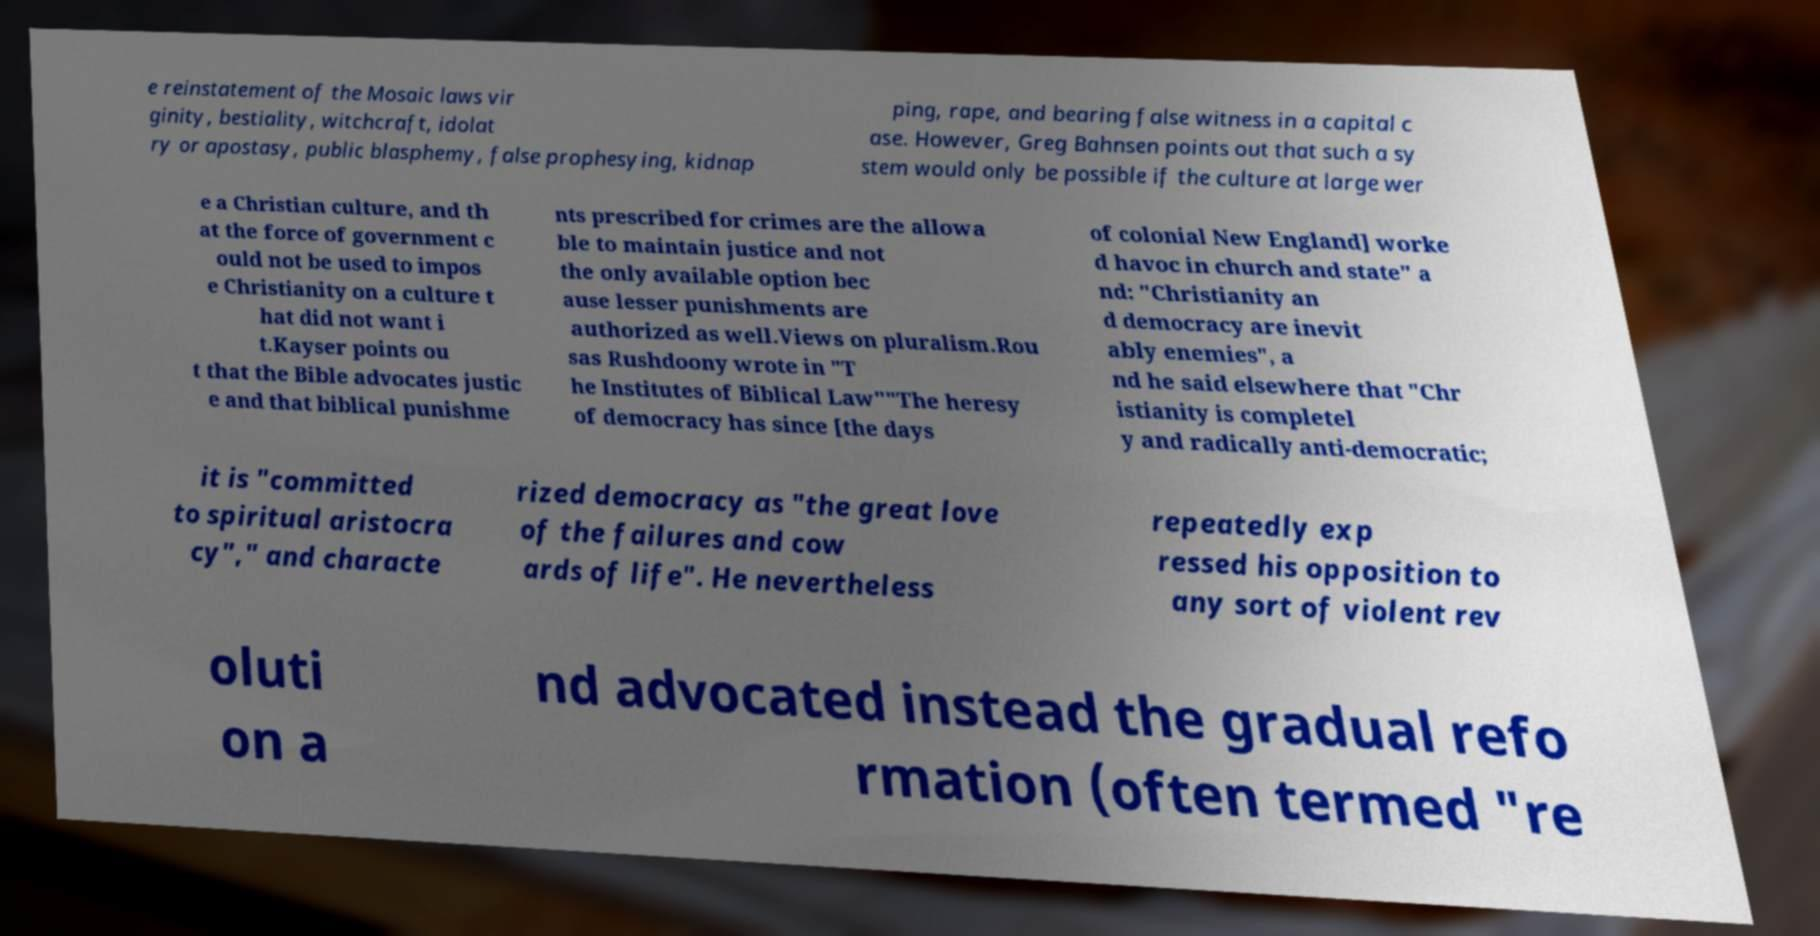There's text embedded in this image that I need extracted. Can you transcribe it verbatim? e reinstatement of the Mosaic laws vir ginity, bestiality, witchcraft, idolat ry or apostasy, public blasphemy, false prophesying, kidnap ping, rape, and bearing false witness in a capital c ase. However, Greg Bahnsen points out that such a sy stem would only be possible if the culture at large wer e a Christian culture, and th at the force of government c ould not be used to impos e Christianity on a culture t hat did not want i t.Kayser points ou t that the Bible advocates justic e and that biblical punishme nts prescribed for crimes are the allowa ble to maintain justice and not the only available option bec ause lesser punishments are authorized as well.Views on pluralism.Rou sas Rushdoony wrote in "T he Institutes of Biblical Law""The heresy of democracy has since [the days of colonial New England] worke d havoc in church and state" a nd: "Christianity an d democracy are inevit ably enemies", a nd he said elsewhere that "Chr istianity is completel y and radically anti-democratic; it is "committed to spiritual aristocra cy"," and characte rized democracy as "the great love of the failures and cow ards of life". He nevertheless repeatedly exp ressed his opposition to any sort of violent rev oluti on a nd advocated instead the gradual refo rmation (often termed "re 